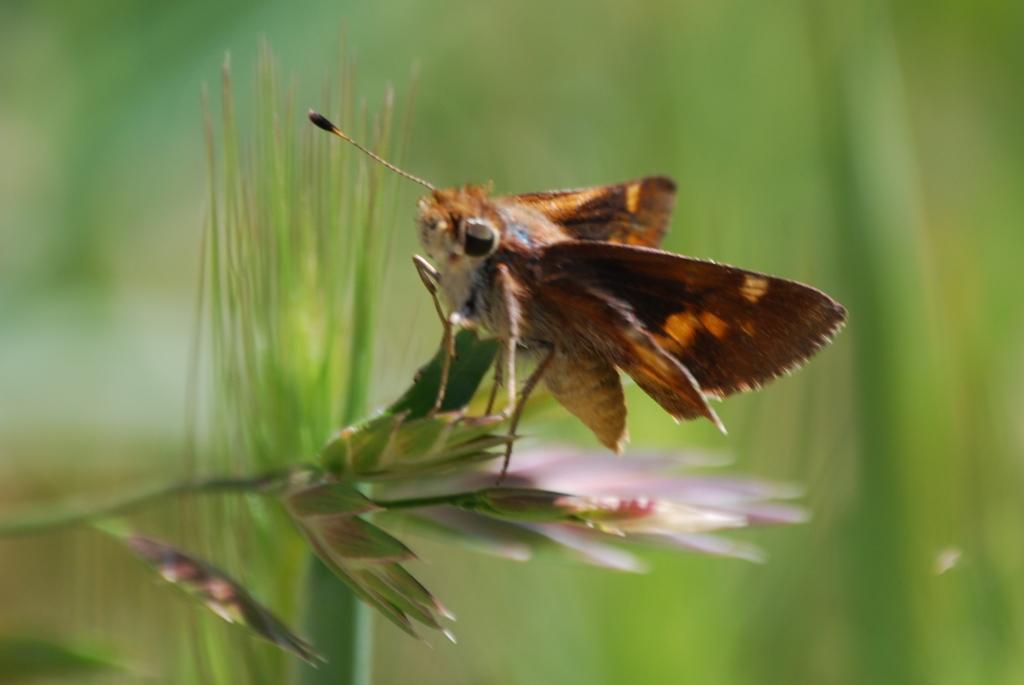How would you summarize this image in a sentence or two? In this image we can see a fly on the plant. 